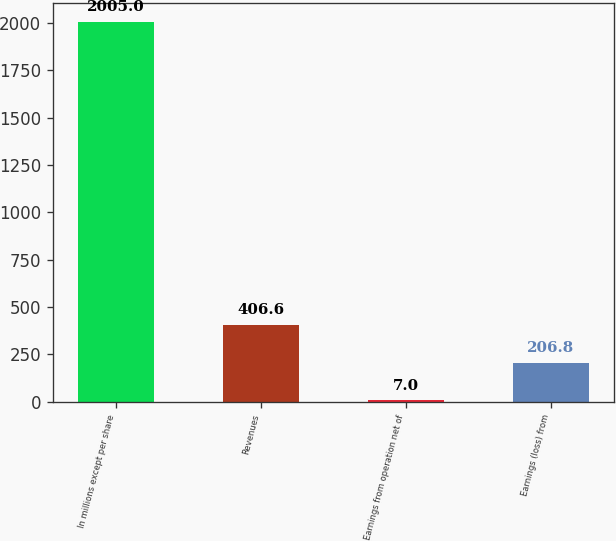<chart> <loc_0><loc_0><loc_500><loc_500><bar_chart><fcel>In millions except per share<fcel>Revenues<fcel>Earnings from operation net of<fcel>Earnings (loss) from<nl><fcel>2005<fcel>406.6<fcel>7<fcel>206.8<nl></chart> 